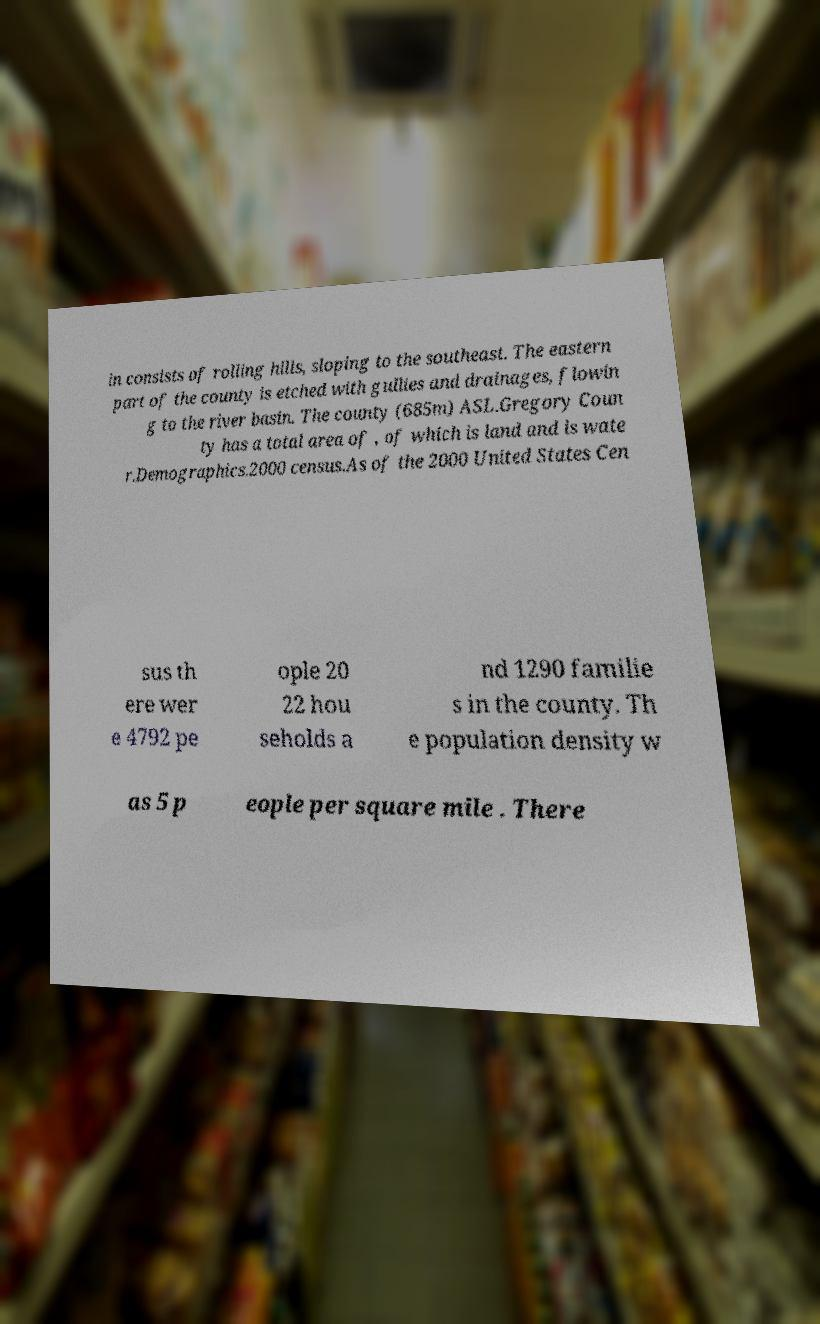Please read and relay the text visible in this image. What does it say? in consists of rolling hills, sloping to the southeast. The eastern part of the county is etched with gullies and drainages, flowin g to the river basin. The county (685m) ASL.Gregory Coun ty has a total area of , of which is land and is wate r.Demographics.2000 census.As of the 2000 United States Cen sus th ere wer e 4792 pe ople 20 22 hou seholds a nd 1290 familie s in the county. Th e population density w as 5 p eople per square mile . There 